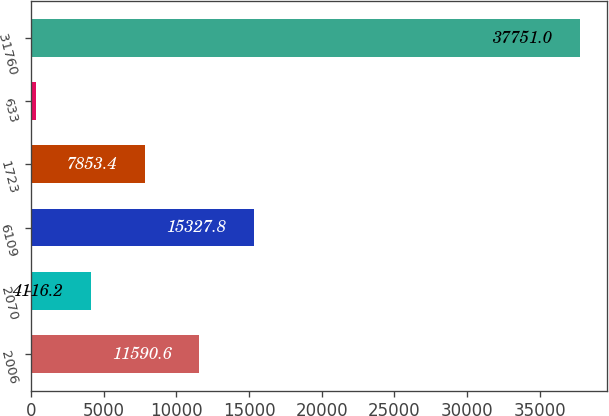Convert chart to OTSL. <chart><loc_0><loc_0><loc_500><loc_500><bar_chart><fcel>2006<fcel>2070<fcel>6109<fcel>1723<fcel>633<fcel>31760<nl><fcel>11590.6<fcel>4116.2<fcel>15327.8<fcel>7853.4<fcel>379<fcel>37751<nl></chart> 